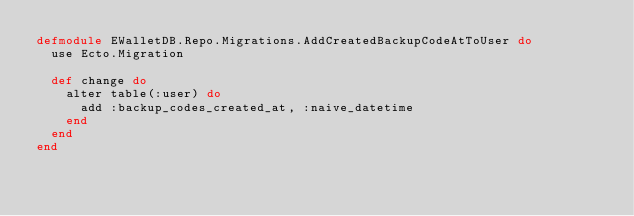<code> <loc_0><loc_0><loc_500><loc_500><_Elixir_>defmodule EWalletDB.Repo.Migrations.AddCreatedBackupCodeAtToUser do
  use Ecto.Migration

  def change do
    alter table(:user) do
      add :backup_codes_created_at, :naive_datetime
    end
  end
end
</code> 